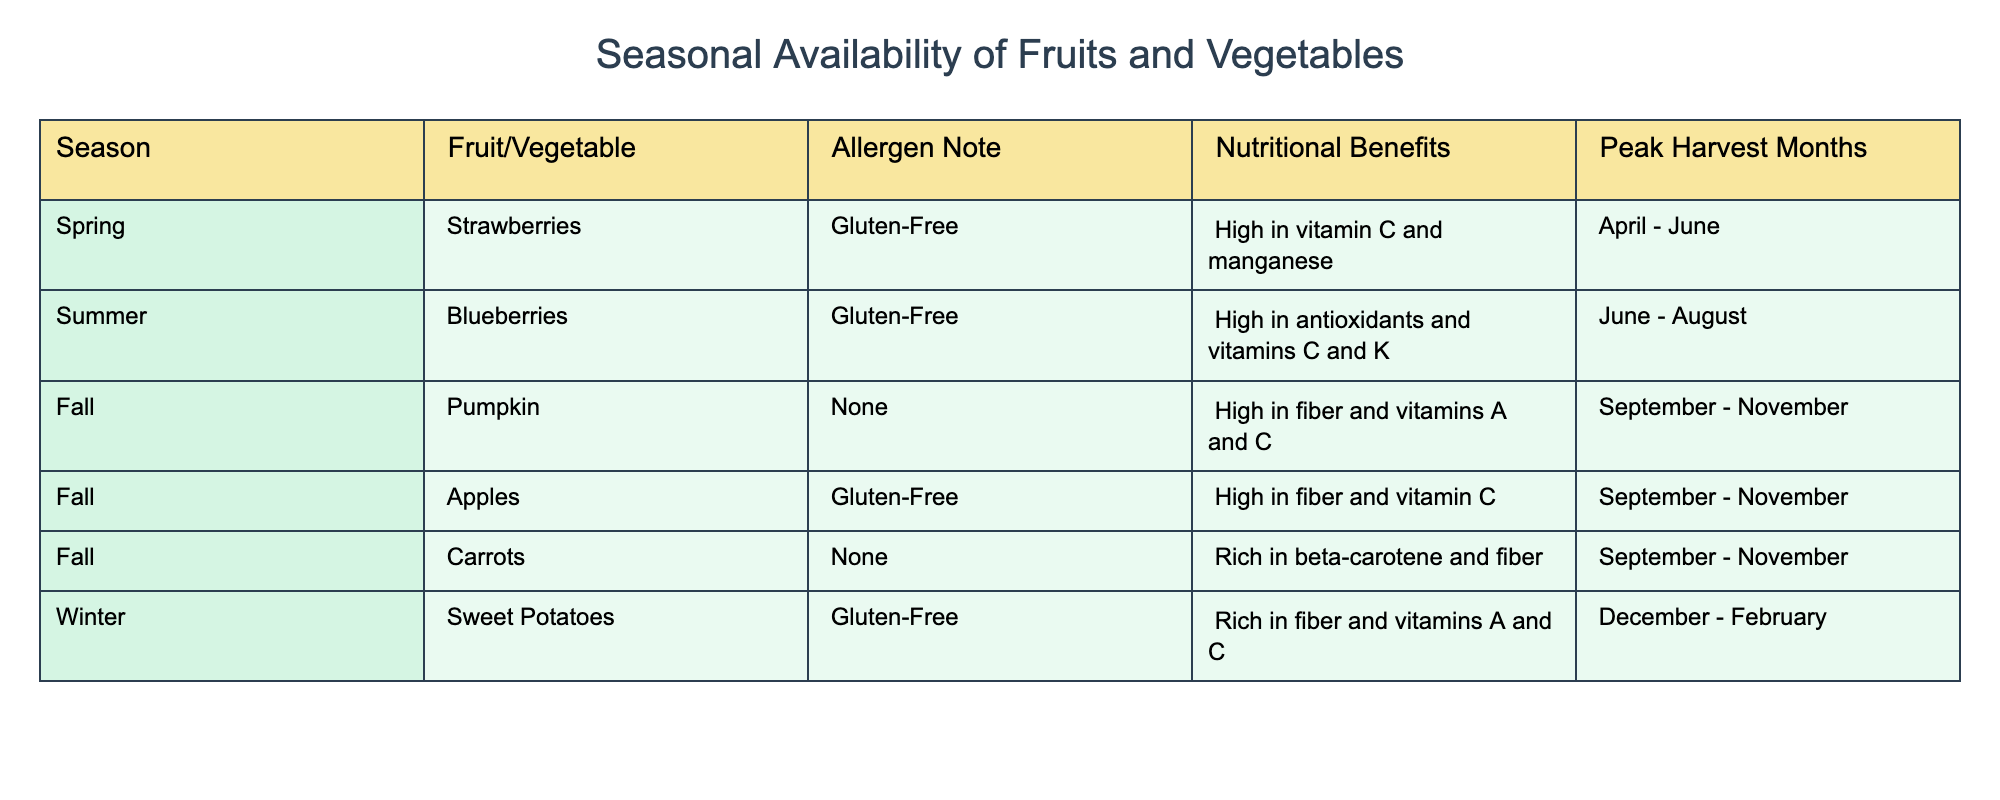What fruits and vegetables are available in the Fall? Referring to the table, the Fall season lists Pumpkin, Apples, and Carrots as available fruits and vegetables.
Answer: Pumpkin, Apples, Carrots Which fruit has the highest nutritional benefit based on vitamin content? The nutritional benefits of Strawberries (high in vitamin C and manganese) and Sweet Potatoes (rich in vitamins A and C) indicate they are significant. However, Sweet Potatoes are noted for a higher vitamin A content, which is crucial for pregnant women.
Answer: Sweet Potatoes Is Blueberries gluten-free? According to the allergen note in the table, Blueberries are listed as gluten-free.
Answer: Yes Which season has the widest variety of allergen-friendly ingredients? The table shows that Fall has three allergen-friendly items (Pumpkin, Apples, Carrots) while Spring and Summer each have one gluten-free item (Strawberries and Blueberries respectively), and Winter has one (Sweet Potatoes). Fall therefore has the widest variety.
Answer: Fall Are Strawberries available year-round? The table specifies that Strawberries are available from April to June, which means they are not available year-round.
Answer: No How many items are gluten-free in the table? The table shows four items marked as gluten-free: Strawberries, Blueberries, Apples, and Sweet Potatoes. Thus, we count these four items to arrive at the answer.
Answer: Four Which season includes Sweet Potatoes and what are their nutritional benefits? Sweet Potatoes are available in Winter, and they are rich in fiber as well as vitamins A and C, according to the nutritional benefits listed in the table.
Answer: Winter; Rich in fiber, vitamins A and C What is the total number of items listed in the table? To find the total number of items, we count each individual fruit and vegetable listed across all seasons: Strawberries, Blueberries, Pumpkin, Apples, Carrots, and Sweet Potatoes, which totals six items.
Answer: Six Which allergen-friendly ingredient is available in Winter? The table states that Sweet Potatoes are the allergen-friendly ingredient available during Winter.
Answer: Sweet Potatoes 